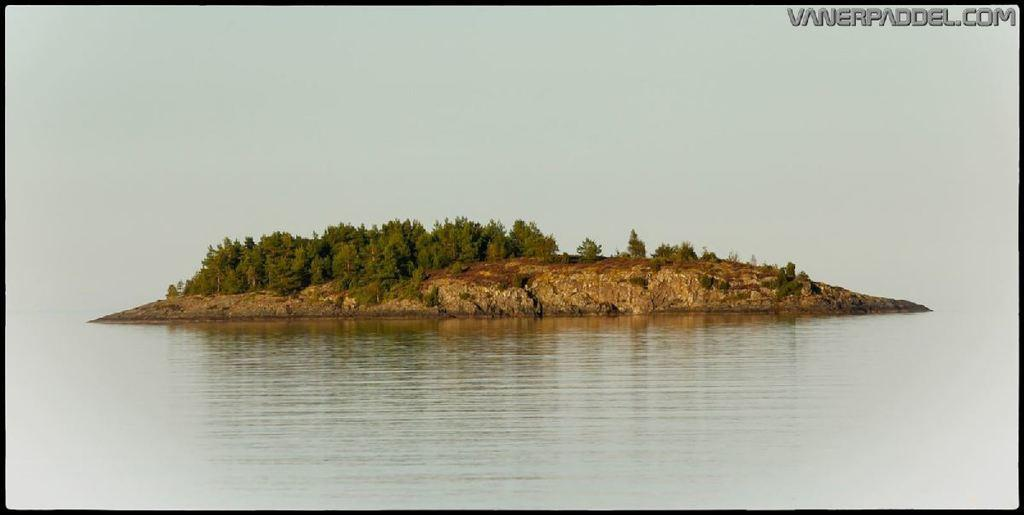What type of vegetation can be seen on the land in the image? There are trees on the land in the image. What natural feature is visible in the background of the image? There is water visible in the background of the image. Where is the text located in the image? The text is in the top right corner of the image. How many trucks are parked under the veil in the image? There are no trucks or veils present in the image. What type of home is visible in the image? There is no home visible in the image; it features trees on land and water in the background. 